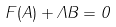Convert formula to latex. <formula><loc_0><loc_0><loc_500><loc_500>F ( A ) + \Lambda B = 0</formula> 